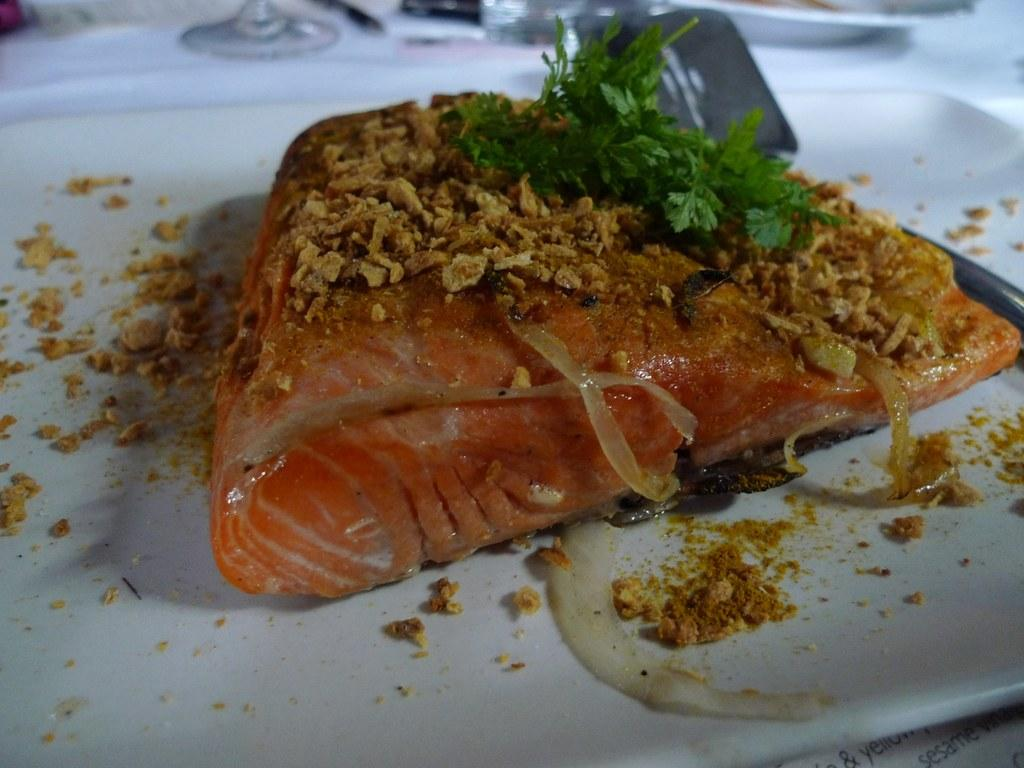What is on the plate that is visible in the image? There is a food item on a plate in the image. What else can be seen in the image besides the plate with food? There are glasses visible in the image. Can you describe the other plate in the image? There is another plate at the top of the image. What type of chair is visible in the image? There is no chair present in the image. Is the food item hot in the image? The provided facts do not mention the temperature of the food item, so it cannot be determined from the image. 